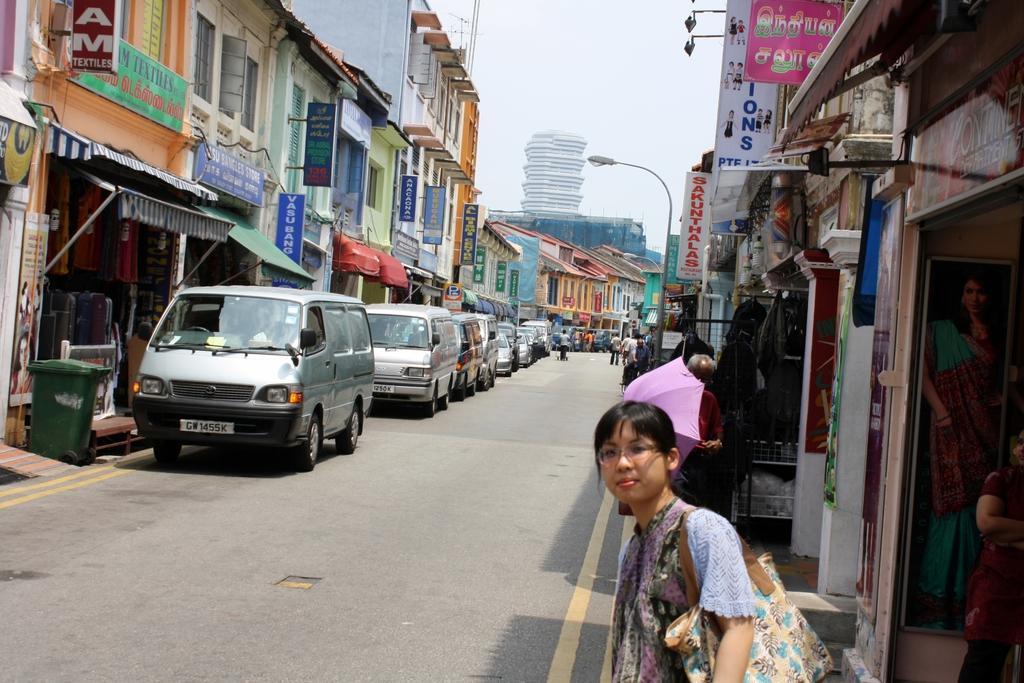How would you summarize this image in a sentence or two? In this image we can see a group of buildings with windows. We can also see the sign boards with some text on them, a trash bin, some vehicles and a group of people on the ground, an umbrella, a photo frame of a person on a wall, a street pole and the sky. In the foreground we can see a woman wearing a bag. 